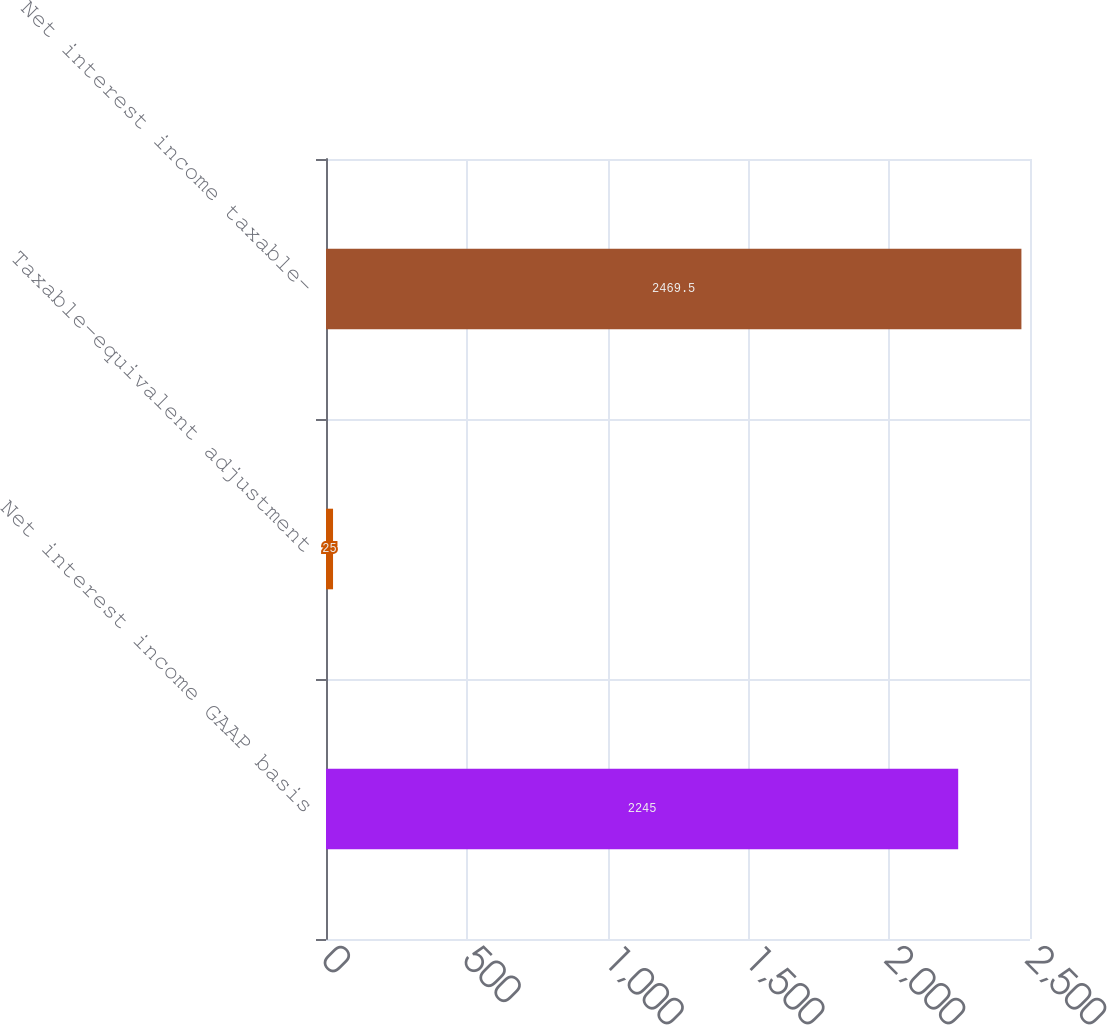Convert chart to OTSL. <chart><loc_0><loc_0><loc_500><loc_500><bar_chart><fcel>Net interest income GAAP basis<fcel>Taxable-equivalent adjustment<fcel>Net interest income taxable-<nl><fcel>2245<fcel>25<fcel>2469.5<nl></chart> 